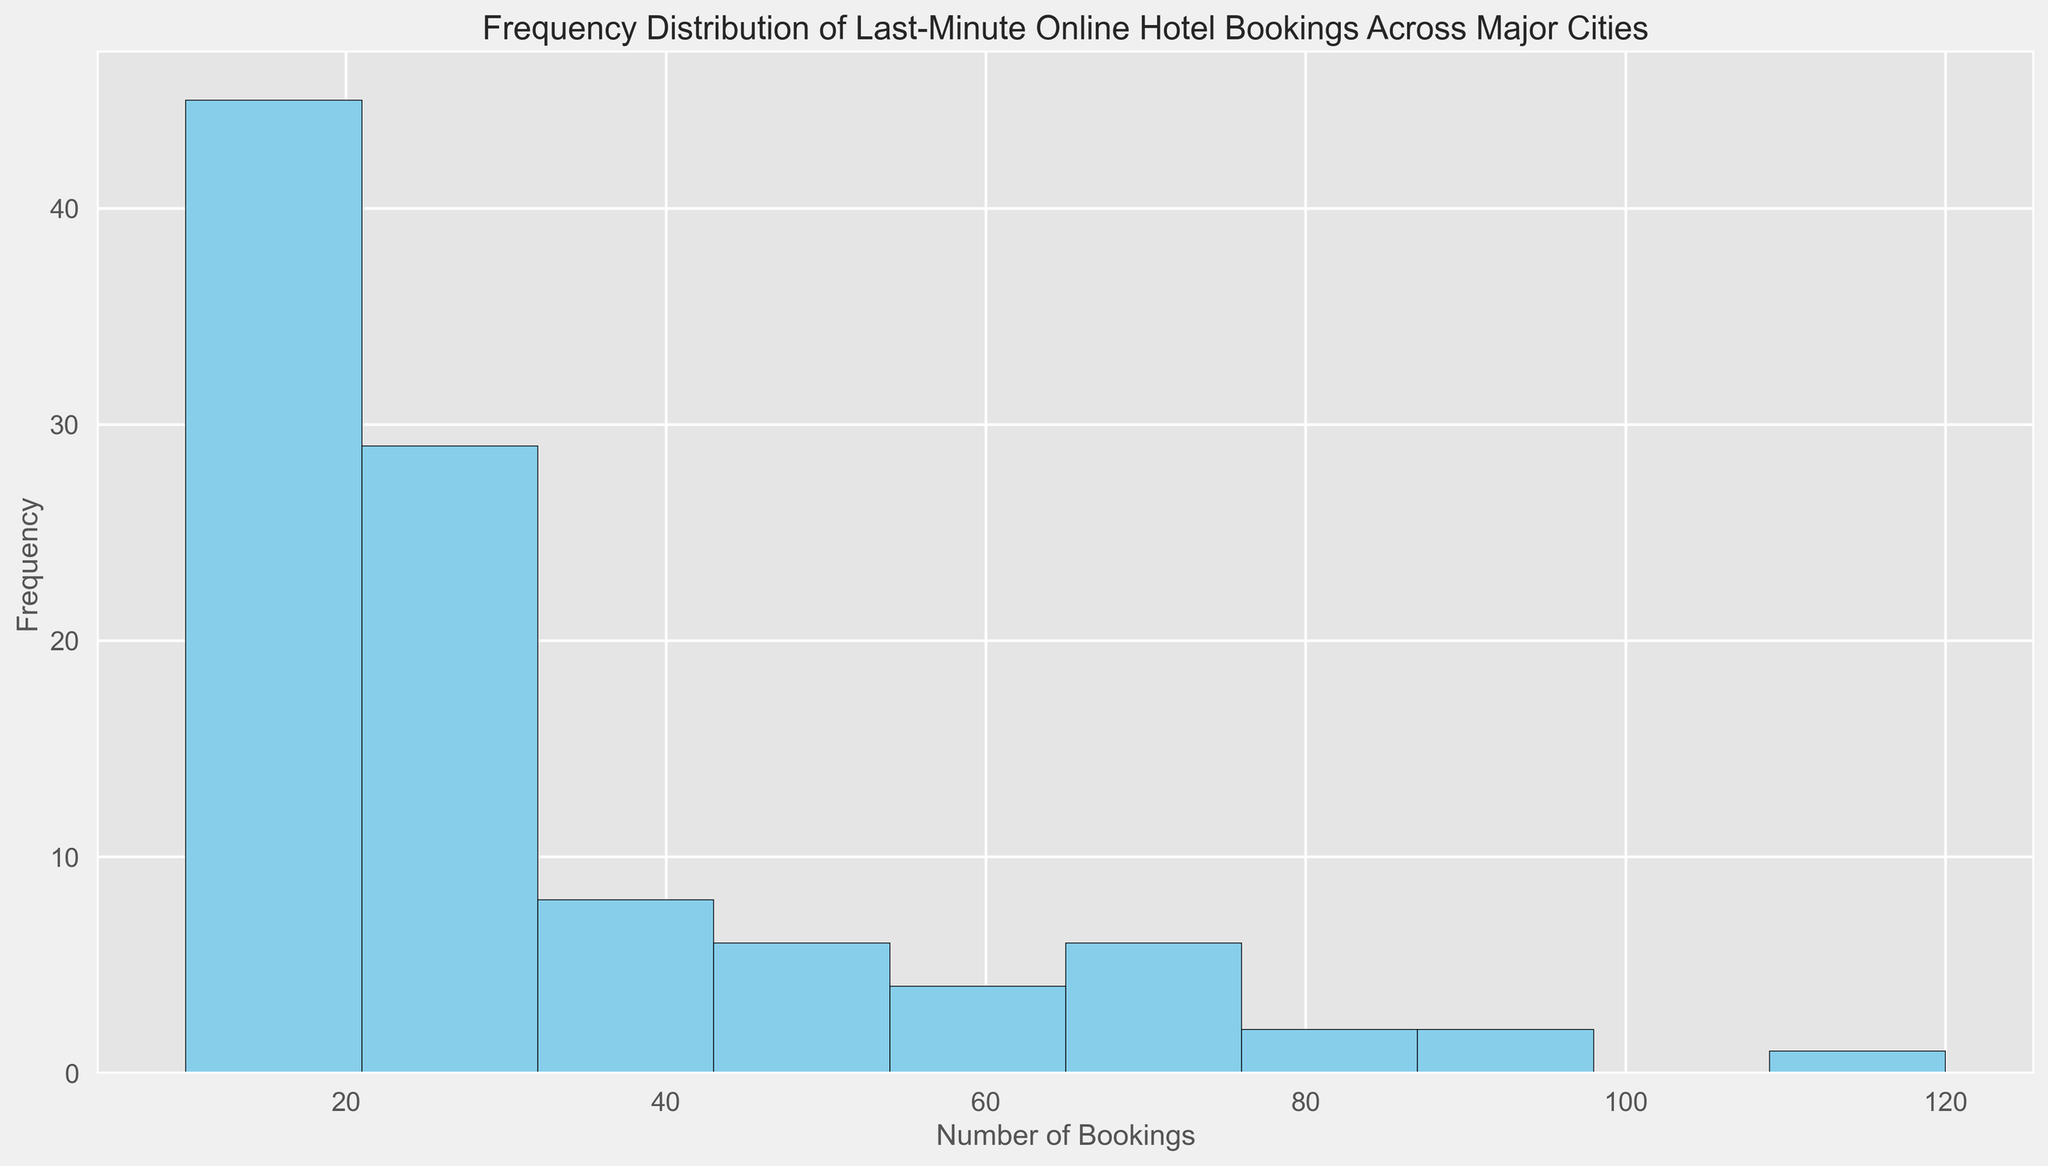What is the most common range for the number of bookings? To determine the most common range, we need to identify the bin with the highest bar (peak) in the histogram. This bin represents the range where the frequency of bookings is greatest.
Answer: 20-30 Which range has the fewest bookings? To find this, we look for the bin with the shortest bar in the histogram. The height of the bar corresponds to the frequency, so the shorter bars represent lower frequencies.
Answer: 80-90 What is the approximate total number of cities with bookings between 30 and 40? This requires identifying the bin that covers the range 30-40 and then counting the cities (frequency) within that bin. In the histogram, the height of the bar for 30-40 gives us this frequency.
Answer: 8 How many cities have more than 90 bookings? In the histogram, we count the bars covering ranges greater than 90 and sum their frequencies.
Answer: 2 Which booking range seems to have similar frequencies to the 40-50 range? We compare the height of the bar in the 40-50 range with other bars to identify similarly sized bars, indicating similar frequencies.
Answer: 50-60 What is the median range of bookings for the cities? The median range is found by sorting the frequencies and identifying the middle value. With approximately 100 cities, the middle data point falls between the 50th and 51st sorted city frequencies. The corresponding bin in the histogram represents this median value.
Answer: 20-30 What percentage of cities have 60 or fewer bookings? Count the cities in all corresponding bins up to 60 and divide by the total number of cities, then multiply by 100 to get the percentage. The bins include 0-10, 10-20, 20-30, 30-40, 40-50, and 50-60. Total cities = 31 + 16 + 8 + 8 + 8 + 8 = 79. (79/100) * 100 = 79%.
Answer: 79% How does the frequency of cities with bookings between 60 and 70 compare to those between 70 and 80? We look at the bars for 60-70 and 70-80 and compare their heights. The taller bar represents the range with the higher frequency.
Answer: Similar What visual characteristics indicate the highest frequency bin in the histogram? The highest frequency bin is indicated by the tallest bar in the histogram. We look for the bar that stands out as the tallest.
Answer: 20-30 